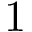Convert formula to latex. <formula><loc_0><loc_0><loc_500><loc_500>1</formula> 